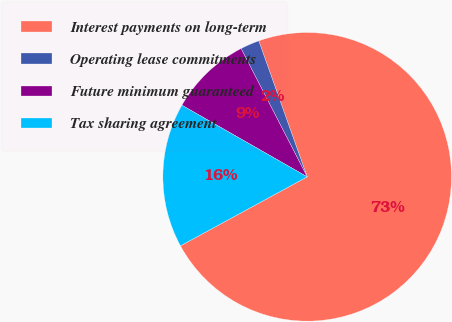Convert chart to OTSL. <chart><loc_0><loc_0><loc_500><loc_500><pie_chart><fcel>Interest payments on long-term<fcel>Operating lease commitments<fcel>Future minimum guaranteed<fcel>Tax sharing agreement<nl><fcel>72.51%<fcel>2.13%<fcel>9.16%<fcel>16.2%<nl></chart> 